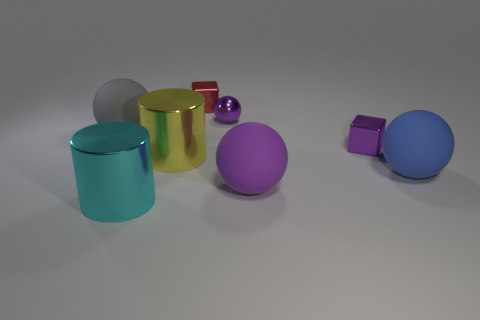Subtract all big gray matte spheres. How many spheres are left? 3 Subtract all gray cubes. How many blue cylinders are left? 0 Add 1 brown rubber blocks. How many objects exist? 9 Subtract all red cubes. How many cubes are left? 1 Subtract 1 gray balls. How many objects are left? 7 Subtract all cylinders. How many objects are left? 6 Subtract 1 cubes. How many cubes are left? 1 Subtract all gray cylinders. Subtract all cyan blocks. How many cylinders are left? 2 Subtract all cyan cylinders. Subtract all small purple metal balls. How many objects are left? 6 Add 3 large gray rubber balls. How many large gray rubber balls are left? 4 